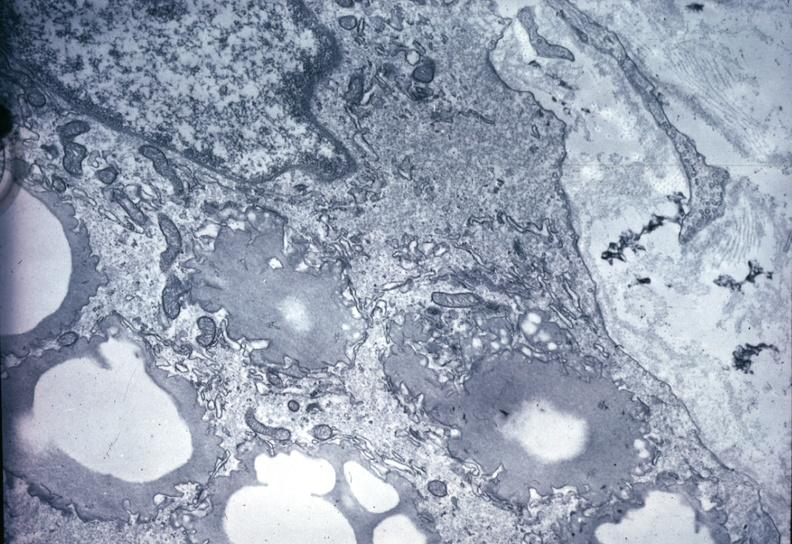what precipitate in interstitial space very good example outside case?
Answer the question using a single word or phrase. This image shows of smooth muscle cell with lipid sarcoplasm and lipid 